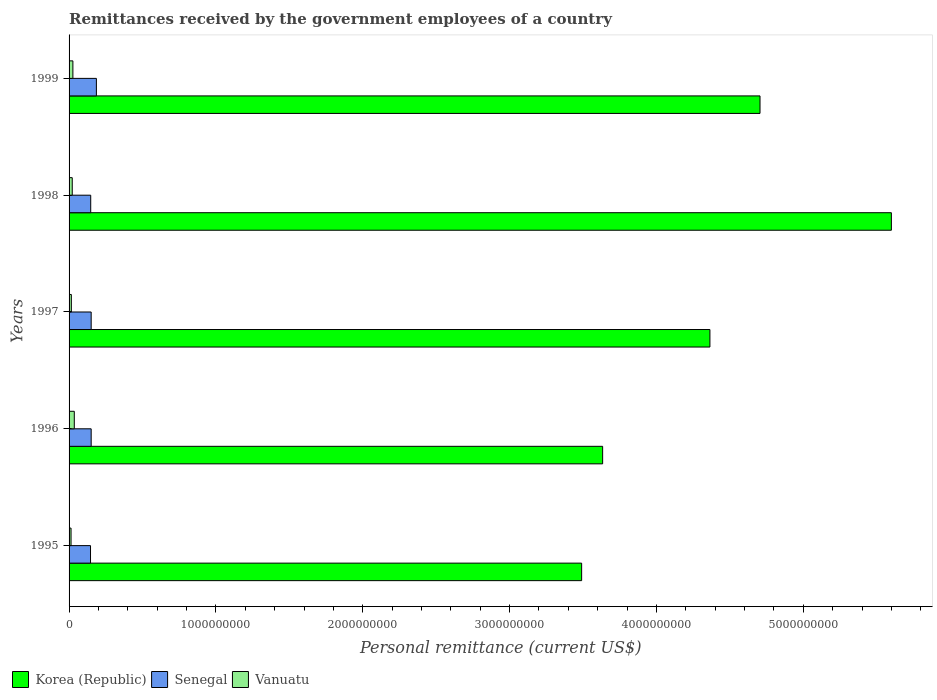How many different coloured bars are there?
Offer a terse response. 3. How many groups of bars are there?
Your answer should be very brief. 5. Are the number of bars on each tick of the Y-axis equal?
Offer a very short reply. Yes. How many bars are there on the 5th tick from the top?
Keep it short and to the point. 3. How many bars are there on the 1st tick from the bottom?
Give a very brief answer. 3. What is the remittances received by the government employees in Senegal in 1996?
Your response must be concise. 1.50e+08. Across all years, what is the maximum remittances received by the government employees in Korea (Republic)?
Your answer should be compact. 5.60e+09. Across all years, what is the minimum remittances received by the government employees in Vanuatu?
Your answer should be very brief. 1.35e+07. In which year was the remittances received by the government employees in Korea (Republic) minimum?
Your answer should be very brief. 1995. What is the total remittances received by the government employees in Korea (Republic) in the graph?
Your answer should be compact. 2.18e+1. What is the difference between the remittances received by the government employees in Korea (Republic) in 1998 and that in 1999?
Ensure brevity in your answer.  8.95e+08. What is the difference between the remittances received by the government employees in Senegal in 1995 and the remittances received by the government employees in Korea (Republic) in 1999?
Your response must be concise. -4.56e+09. What is the average remittances received by the government employees in Senegal per year?
Give a very brief answer. 1.56e+08. In the year 1998, what is the difference between the remittances received by the government employees in Vanuatu and remittances received by the government employees in Korea (Republic)?
Offer a terse response. -5.58e+09. What is the ratio of the remittances received by the government employees in Korea (Republic) in 1996 to that in 1998?
Your response must be concise. 0.65. Is the difference between the remittances received by the government employees in Vanuatu in 1998 and 1999 greater than the difference between the remittances received by the government employees in Korea (Republic) in 1998 and 1999?
Ensure brevity in your answer.  No. What is the difference between the highest and the second highest remittances received by the government employees in Senegal?
Keep it short and to the point. 3.56e+07. What is the difference between the highest and the lowest remittances received by the government employees in Vanuatu?
Keep it short and to the point. 2.21e+07. What does the 1st bar from the top in 1999 represents?
Provide a succinct answer. Vanuatu. Is it the case that in every year, the sum of the remittances received by the government employees in Senegal and remittances received by the government employees in Vanuatu is greater than the remittances received by the government employees in Korea (Republic)?
Give a very brief answer. No. How many bars are there?
Offer a terse response. 15. Are all the bars in the graph horizontal?
Your answer should be compact. Yes. How many years are there in the graph?
Your answer should be very brief. 5. What is the difference between two consecutive major ticks on the X-axis?
Give a very brief answer. 1.00e+09. Does the graph contain any zero values?
Keep it short and to the point. No. Does the graph contain grids?
Offer a terse response. No. How are the legend labels stacked?
Your answer should be compact. Horizontal. What is the title of the graph?
Offer a terse response. Remittances received by the government employees of a country. Does "High income" appear as one of the legend labels in the graph?
Your answer should be very brief. No. What is the label or title of the X-axis?
Keep it short and to the point. Personal remittance (current US$). What is the label or title of the Y-axis?
Your response must be concise. Years. What is the Personal remittance (current US$) in Korea (Republic) in 1995?
Offer a terse response. 3.49e+09. What is the Personal remittance (current US$) in Senegal in 1995?
Make the answer very short. 1.46e+08. What is the Personal remittance (current US$) of Vanuatu in 1995?
Your response must be concise. 1.35e+07. What is the Personal remittance (current US$) in Korea (Republic) in 1996?
Make the answer very short. 3.63e+09. What is the Personal remittance (current US$) in Senegal in 1996?
Give a very brief answer. 1.50e+08. What is the Personal remittance (current US$) in Vanuatu in 1996?
Give a very brief answer. 3.56e+07. What is the Personal remittance (current US$) of Korea (Republic) in 1997?
Give a very brief answer. 4.36e+09. What is the Personal remittance (current US$) of Senegal in 1997?
Keep it short and to the point. 1.50e+08. What is the Personal remittance (current US$) in Vanuatu in 1997?
Your response must be concise. 1.55e+07. What is the Personal remittance (current US$) in Korea (Republic) in 1998?
Keep it short and to the point. 5.60e+09. What is the Personal remittance (current US$) in Senegal in 1998?
Offer a terse response. 1.47e+08. What is the Personal remittance (current US$) of Vanuatu in 1998?
Keep it short and to the point. 2.16e+07. What is the Personal remittance (current US$) in Korea (Republic) in 1999?
Make the answer very short. 4.71e+09. What is the Personal remittance (current US$) of Senegal in 1999?
Your response must be concise. 1.86e+08. What is the Personal remittance (current US$) in Vanuatu in 1999?
Offer a very short reply. 2.60e+07. Across all years, what is the maximum Personal remittance (current US$) in Korea (Republic)?
Keep it short and to the point. 5.60e+09. Across all years, what is the maximum Personal remittance (current US$) in Senegal?
Provide a short and direct response. 1.86e+08. Across all years, what is the maximum Personal remittance (current US$) of Vanuatu?
Provide a succinct answer. 3.56e+07. Across all years, what is the minimum Personal remittance (current US$) in Korea (Republic)?
Keep it short and to the point. 3.49e+09. Across all years, what is the minimum Personal remittance (current US$) of Senegal?
Your answer should be very brief. 1.46e+08. Across all years, what is the minimum Personal remittance (current US$) in Vanuatu?
Provide a short and direct response. 1.35e+07. What is the total Personal remittance (current US$) in Korea (Republic) in the graph?
Provide a short and direct response. 2.18e+1. What is the total Personal remittance (current US$) of Senegal in the graph?
Provide a short and direct response. 7.80e+08. What is the total Personal remittance (current US$) in Vanuatu in the graph?
Your answer should be compact. 1.12e+08. What is the difference between the Personal remittance (current US$) of Korea (Republic) in 1995 and that in 1996?
Your response must be concise. -1.43e+08. What is the difference between the Personal remittance (current US$) in Senegal in 1995 and that in 1996?
Your answer should be compact. -4.45e+06. What is the difference between the Personal remittance (current US$) of Vanuatu in 1995 and that in 1996?
Provide a succinct answer. -2.21e+07. What is the difference between the Personal remittance (current US$) in Korea (Republic) in 1995 and that in 1997?
Keep it short and to the point. -8.74e+08. What is the difference between the Personal remittance (current US$) of Senegal in 1995 and that in 1997?
Offer a very short reply. -4.44e+06. What is the difference between the Personal remittance (current US$) of Vanuatu in 1995 and that in 1997?
Offer a terse response. -2.02e+06. What is the difference between the Personal remittance (current US$) in Korea (Republic) in 1995 and that in 1998?
Your response must be concise. -2.11e+09. What is the difference between the Personal remittance (current US$) in Senegal in 1995 and that in 1998?
Give a very brief answer. -1.39e+06. What is the difference between the Personal remittance (current US$) in Vanuatu in 1995 and that in 1998?
Offer a terse response. -8.10e+06. What is the difference between the Personal remittance (current US$) of Korea (Republic) in 1995 and that in 1999?
Your answer should be compact. -1.21e+09. What is the difference between the Personal remittance (current US$) in Senegal in 1995 and that in 1999?
Offer a very short reply. -4.00e+07. What is the difference between the Personal remittance (current US$) in Vanuatu in 1995 and that in 1999?
Ensure brevity in your answer.  -1.25e+07. What is the difference between the Personal remittance (current US$) in Korea (Republic) in 1996 and that in 1997?
Your answer should be compact. -7.31e+08. What is the difference between the Personal remittance (current US$) in Senegal in 1996 and that in 1997?
Give a very brief answer. 1.39e+04. What is the difference between the Personal remittance (current US$) of Vanuatu in 1996 and that in 1997?
Provide a succinct answer. 2.00e+07. What is the difference between the Personal remittance (current US$) of Korea (Republic) in 1996 and that in 1998?
Ensure brevity in your answer.  -1.97e+09. What is the difference between the Personal remittance (current US$) in Senegal in 1996 and that in 1998?
Offer a very short reply. 3.06e+06. What is the difference between the Personal remittance (current US$) in Vanuatu in 1996 and that in 1998?
Your answer should be very brief. 1.40e+07. What is the difference between the Personal remittance (current US$) in Korea (Republic) in 1996 and that in 1999?
Keep it short and to the point. -1.07e+09. What is the difference between the Personal remittance (current US$) in Senegal in 1996 and that in 1999?
Ensure brevity in your answer.  -3.56e+07. What is the difference between the Personal remittance (current US$) in Vanuatu in 1996 and that in 1999?
Keep it short and to the point. 9.60e+06. What is the difference between the Personal remittance (current US$) in Korea (Republic) in 1997 and that in 1998?
Offer a terse response. -1.24e+09. What is the difference between the Personal remittance (current US$) of Senegal in 1997 and that in 1998?
Ensure brevity in your answer.  3.05e+06. What is the difference between the Personal remittance (current US$) in Vanuatu in 1997 and that in 1998?
Give a very brief answer. -6.08e+06. What is the difference between the Personal remittance (current US$) in Korea (Republic) in 1997 and that in 1999?
Provide a short and direct response. -3.41e+08. What is the difference between the Personal remittance (current US$) of Senegal in 1997 and that in 1999?
Your answer should be very brief. -3.56e+07. What is the difference between the Personal remittance (current US$) in Vanuatu in 1997 and that in 1999?
Keep it short and to the point. -1.04e+07. What is the difference between the Personal remittance (current US$) of Korea (Republic) in 1998 and that in 1999?
Your answer should be compact. 8.95e+08. What is the difference between the Personal remittance (current US$) in Senegal in 1998 and that in 1999?
Give a very brief answer. -3.86e+07. What is the difference between the Personal remittance (current US$) of Vanuatu in 1998 and that in 1999?
Ensure brevity in your answer.  -4.36e+06. What is the difference between the Personal remittance (current US$) of Korea (Republic) in 1995 and the Personal remittance (current US$) of Senegal in 1996?
Your answer should be very brief. 3.34e+09. What is the difference between the Personal remittance (current US$) of Korea (Republic) in 1995 and the Personal remittance (current US$) of Vanuatu in 1996?
Provide a succinct answer. 3.45e+09. What is the difference between the Personal remittance (current US$) of Senegal in 1995 and the Personal remittance (current US$) of Vanuatu in 1996?
Provide a short and direct response. 1.10e+08. What is the difference between the Personal remittance (current US$) of Korea (Republic) in 1995 and the Personal remittance (current US$) of Senegal in 1997?
Ensure brevity in your answer.  3.34e+09. What is the difference between the Personal remittance (current US$) in Korea (Republic) in 1995 and the Personal remittance (current US$) in Vanuatu in 1997?
Your answer should be compact. 3.47e+09. What is the difference between the Personal remittance (current US$) of Senegal in 1995 and the Personal remittance (current US$) of Vanuatu in 1997?
Offer a terse response. 1.30e+08. What is the difference between the Personal remittance (current US$) in Korea (Republic) in 1995 and the Personal remittance (current US$) in Senegal in 1998?
Offer a terse response. 3.34e+09. What is the difference between the Personal remittance (current US$) of Korea (Republic) in 1995 and the Personal remittance (current US$) of Vanuatu in 1998?
Offer a very short reply. 3.47e+09. What is the difference between the Personal remittance (current US$) in Senegal in 1995 and the Personal remittance (current US$) in Vanuatu in 1998?
Offer a very short reply. 1.24e+08. What is the difference between the Personal remittance (current US$) of Korea (Republic) in 1995 and the Personal remittance (current US$) of Senegal in 1999?
Make the answer very short. 3.30e+09. What is the difference between the Personal remittance (current US$) of Korea (Republic) in 1995 and the Personal remittance (current US$) of Vanuatu in 1999?
Provide a short and direct response. 3.46e+09. What is the difference between the Personal remittance (current US$) of Senegal in 1995 and the Personal remittance (current US$) of Vanuatu in 1999?
Give a very brief answer. 1.20e+08. What is the difference between the Personal remittance (current US$) in Korea (Republic) in 1996 and the Personal remittance (current US$) in Senegal in 1997?
Give a very brief answer. 3.48e+09. What is the difference between the Personal remittance (current US$) of Korea (Republic) in 1996 and the Personal remittance (current US$) of Vanuatu in 1997?
Your answer should be compact. 3.62e+09. What is the difference between the Personal remittance (current US$) in Senegal in 1996 and the Personal remittance (current US$) in Vanuatu in 1997?
Give a very brief answer. 1.35e+08. What is the difference between the Personal remittance (current US$) in Korea (Republic) in 1996 and the Personal remittance (current US$) in Senegal in 1998?
Keep it short and to the point. 3.49e+09. What is the difference between the Personal remittance (current US$) of Korea (Republic) in 1996 and the Personal remittance (current US$) of Vanuatu in 1998?
Provide a short and direct response. 3.61e+09. What is the difference between the Personal remittance (current US$) in Senegal in 1996 and the Personal remittance (current US$) in Vanuatu in 1998?
Offer a very short reply. 1.29e+08. What is the difference between the Personal remittance (current US$) in Korea (Republic) in 1996 and the Personal remittance (current US$) in Senegal in 1999?
Keep it short and to the point. 3.45e+09. What is the difference between the Personal remittance (current US$) in Korea (Republic) in 1996 and the Personal remittance (current US$) in Vanuatu in 1999?
Offer a very short reply. 3.61e+09. What is the difference between the Personal remittance (current US$) in Senegal in 1996 and the Personal remittance (current US$) in Vanuatu in 1999?
Offer a very short reply. 1.25e+08. What is the difference between the Personal remittance (current US$) in Korea (Republic) in 1997 and the Personal remittance (current US$) in Senegal in 1998?
Your response must be concise. 4.22e+09. What is the difference between the Personal remittance (current US$) of Korea (Republic) in 1997 and the Personal remittance (current US$) of Vanuatu in 1998?
Ensure brevity in your answer.  4.34e+09. What is the difference between the Personal remittance (current US$) in Senegal in 1997 and the Personal remittance (current US$) in Vanuatu in 1998?
Your answer should be compact. 1.29e+08. What is the difference between the Personal remittance (current US$) of Korea (Republic) in 1997 and the Personal remittance (current US$) of Senegal in 1999?
Offer a terse response. 4.18e+09. What is the difference between the Personal remittance (current US$) of Korea (Republic) in 1997 and the Personal remittance (current US$) of Vanuatu in 1999?
Keep it short and to the point. 4.34e+09. What is the difference between the Personal remittance (current US$) of Senegal in 1997 and the Personal remittance (current US$) of Vanuatu in 1999?
Provide a short and direct response. 1.24e+08. What is the difference between the Personal remittance (current US$) of Korea (Republic) in 1998 and the Personal remittance (current US$) of Senegal in 1999?
Your answer should be compact. 5.41e+09. What is the difference between the Personal remittance (current US$) of Korea (Republic) in 1998 and the Personal remittance (current US$) of Vanuatu in 1999?
Provide a short and direct response. 5.57e+09. What is the difference between the Personal remittance (current US$) of Senegal in 1998 and the Personal remittance (current US$) of Vanuatu in 1999?
Provide a succinct answer. 1.21e+08. What is the average Personal remittance (current US$) in Korea (Republic) per year?
Offer a very short reply. 4.36e+09. What is the average Personal remittance (current US$) of Senegal per year?
Offer a very short reply. 1.56e+08. What is the average Personal remittance (current US$) of Vanuatu per year?
Your response must be concise. 2.24e+07. In the year 1995, what is the difference between the Personal remittance (current US$) of Korea (Republic) and Personal remittance (current US$) of Senegal?
Offer a terse response. 3.34e+09. In the year 1995, what is the difference between the Personal remittance (current US$) in Korea (Republic) and Personal remittance (current US$) in Vanuatu?
Keep it short and to the point. 3.48e+09. In the year 1995, what is the difference between the Personal remittance (current US$) in Senegal and Personal remittance (current US$) in Vanuatu?
Provide a short and direct response. 1.33e+08. In the year 1996, what is the difference between the Personal remittance (current US$) of Korea (Republic) and Personal remittance (current US$) of Senegal?
Offer a terse response. 3.48e+09. In the year 1996, what is the difference between the Personal remittance (current US$) of Korea (Republic) and Personal remittance (current US$) of Vanuatu?
Offer a terse response. 3.60e+09. In the year 1996, what is the difference between the Personal remittance (current US$) in Senegal and Personal remittance (current US$) in Vanuatu?
Ensure brevity in your answer.  1.15e+08. In the year 1997, what is the difference between the Personal remittance (current US$) in Korea (Republic) and Personal remittance (current US$) in Senegal?
Offer a very short reply. 4.21e+09. In the year 1997, what is the difference between the Personal remittance (current US$) of Korea (Republic) and Personal remittance (current US$) of Vanuatu?
Your answer should be compact. 4.35e+09. In the year 1997, what is the difference between the Personal remittance (current US$) in Senegal and Personal remittance (current US$) in Vanuatu?
Your response must be concise. 1.35e+08. In the year 1998, what is the difference between the Personal remittance (current US$) in Korea (Republic) and Personal remittance (current US$) in Senegal?
Make the answer very short. 5.45e+09. In the year 1998, what is the difference between the Personal remittance (current US$) of Korea (Republic) and Personal remittance (current US$) of Vanuatu?
Your answer should be compact. 5.58e+09. In the year 1998, what is the difference between the Personal remittance (current US$) of Senegal and Personal remittance (current US$) of Vanuatu?
Offer a very short reply. 1.26e+08. In the year 1999, what is the difference between the Personal remittance (current US$) in Korea (Republic) and Personal remittance (current US$) in Senegal?
Give a very brief answer. 4.52e+09. In the year 1999, what is the difference between the Personal remittance (current US$) of Korea (Republic) and Personal remittance (current US$) of Vanuatu?
Your answer should be compact. 4.68e+09. In the year 1999, what is the difference between the Personal remittance (current US$) of Senegal and Personal remittance (current US$) of Vanuatu?
Offer a very short reply. 1.60e+08. What is the ratio of the Personal remittance (current US$) in Korea (Republic) in 1995 to that in 1996?
Offer a terse response. 0.96. What is the ratio of the Personal remittance (current US$) in Senegal in 1995 to that in 1996?
Provide a succinct answer. 0.97. What is the ratio of the Personal remittance (current US$) in Vanuatu in 1995 to that in 1996?
Provide a succinct answer. 0.38. What is the ratio of the Personal remittance (current US$) in Korea (Republic) in 1995 to that in 1997?
Offer a very short reply. 0.8. What is the ratio of the Personal remittance (current US$) of Senegal in 1995 to that in 1997?
Provide a succinct answer. 0.97. What is the ratio of the Personal remittance (current US$) in Vanuatu in 1995 to that in 1997?
Provide a succinct answer. 0.87. What is the ratio of the Personal remittance (current US$) of Korea (Republic) in 1995 to that in 1998?
Offer a terse response. 0.62. What is the ratio of the Personal remittance (current US$) in Senegal in 1995 to that in 1998?
Ensure brevity in your answer.  0.99. What is the ratio of the Personal remittance (current US$) in Vanuatu in 1995 to that in 1998?
Provide a short and direct response. 0.63. What is the ratio of the Personal remittance (current US$) in Korea (Republic) in 1995 to that in 1999?
Provide a succinct answer. 0.74. What is the ratio of the Personal remittance (current US$) in Senegal in 1995 to that in 1999?
Give a very brief answer. 0.79. What is the ratio of the Personal remittance (current US$) of Vanuatu in 1995 to that in 1999?
Offer a very short reply. 0.52. What is the ratio of the Personal remittance (current US$) of Korea (Republic) in 1996 to that in 1997?
Provide a short and direct response. 0.83. What is the ratio of the Personal remittance (current US$) of Senegal in 1996 to that in 1997?
Your response must be concise. 1. What is the ratio of the Personal remittance (current US$) of Vanuatu in 1996 to that in 1997?
Offer a very short reply. 2.29. What is the ratio of the Personal remittance (current US$) of Korea (Republic) in 1996 to that in 1998?
Keep it short and to the point. 0.65. What is the ratio of the Personal remittance (current US$) of Senegal in 1996 to that in 1998?
Ensure brevity in your answer.  1.02. What is the ratio of the Personal remittance (current US$) of Vanuatu in 1996 to that in 1998?
Offer a very short reply. 1.65. What is the ratio of the Personal remittance (current US$) in Korea (Republic) in 1996 to that in 1999?
Give a very brief answer. 0.77. What is the ratio of the Personal remittance (current US$) of Senegal in 1996 to that in 1999?
Your response must be concise. 0.81. What is the ratio of the Personal remittance (current US$) of Vanuatu in 1996 to that in 1999?
Make the answer very short. 1.37. What is the ratio of the Personal remittance (current US$) of Korea (Republic) in 1997 to that in 1998?
Offer a very short reply. 0.78. What is the ratio of the Personal remittance (current US$) in Senegal in 1997 to that in 1998?
Your answer should be very brief. 1.02. What is the ratio of the Personal remittance (current US$) in Vanuatu in 1997 to that in 1998?
Give a very brief answer. 0.72. What is the ratio of the Personal remittance (current US$) of Korea (Republic) in 1997 to that in 1999?
Provide a short and direct response. 0.93. What is the ratio of the Personal remittance (current US$) of Senegal in 1997 to that in 1999?
Your response must be concise. 0.81. What is the ratio of the Personal remittance (current US$) in Vanuatu in 1997 to that in 1999?
Your response must be concise. 0.6. What is the ratio of the Personal remittance (current US$) in Korea (Republic) in 1998 to that in 1999?
Make the answer very short. 1.19. What is the ratio of the Personal remittance (current US$) of Senegal in 1998 to that in 1999?
Your answer should be very brief. 0.79. What is the ratio of the Personal remittance (current US$) in Vanuatu in 1998 to that in 1999?
Ensure brevity in your answer.  0.83. What is the difference between the highest and the second highest Personal remittance (current US$) of Korea (Republic)?
Make the answer very short. 8.95e+08. What is the difference between the highest and the second highest Personal remittance (current US$) in Senegal?
Keep it short and to the point. 3.56e+07. What is the difference between the highest and the second highest Personal remittance (current US$) in Vanuatu?
Provide a succinct answer. 9.60e+06. What is the difference between the highest and the lowest Personal remittance (current US$) of Korea (Republic)?
Ensure brevity in your answer.  2.11e+09. What is the difference between the highest and the lowest Personal remittance (current US$) of Senegal?
Your answer should be compact. 4.00e+07. What is the difference between the highest and the lowest Personal remittance (current US$) of Vanuatu?
Make the answer very short. 2.21e+07. 